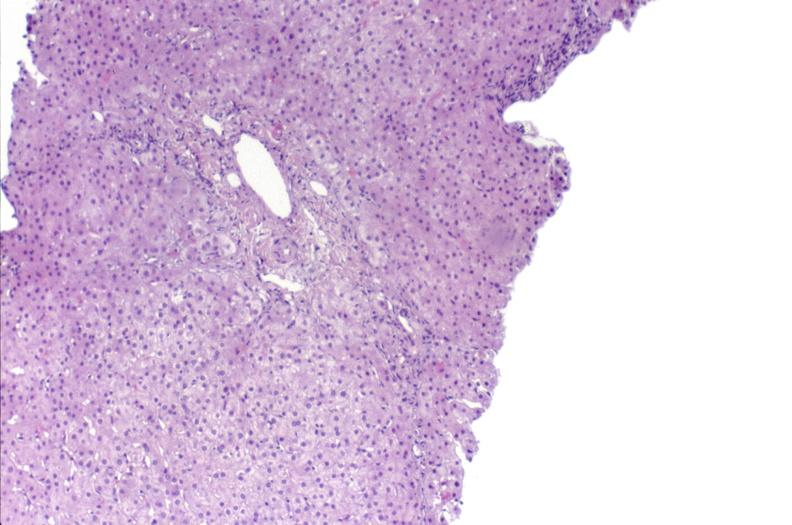s hepatobiliary present?
Answer the question using a single word or phrase. Yes 